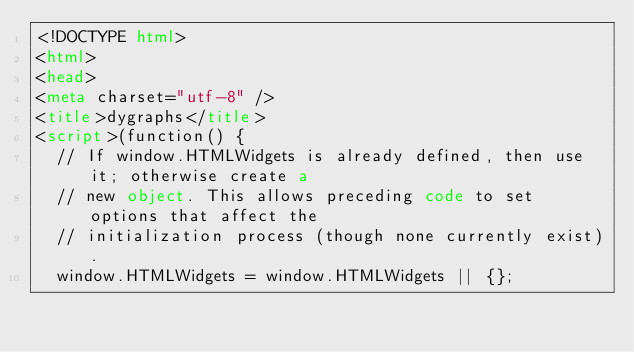<code> <loc_0><loc_0><loc_500><loc_500><_HTML_><!DOCTYPE html>
<html>
<head>
<meta charset="utf-8" />
<title>dygraphs</title>
<script>(function() {
  // If window.HTMLWidgets is already defined, then use it; otherwise create a
  // new object. This allows preceding code to set options that affect the
  // initialization process (though none currently exist).
  window.HTMLWidgets = window.HTMLWidgets || {};
</code> 